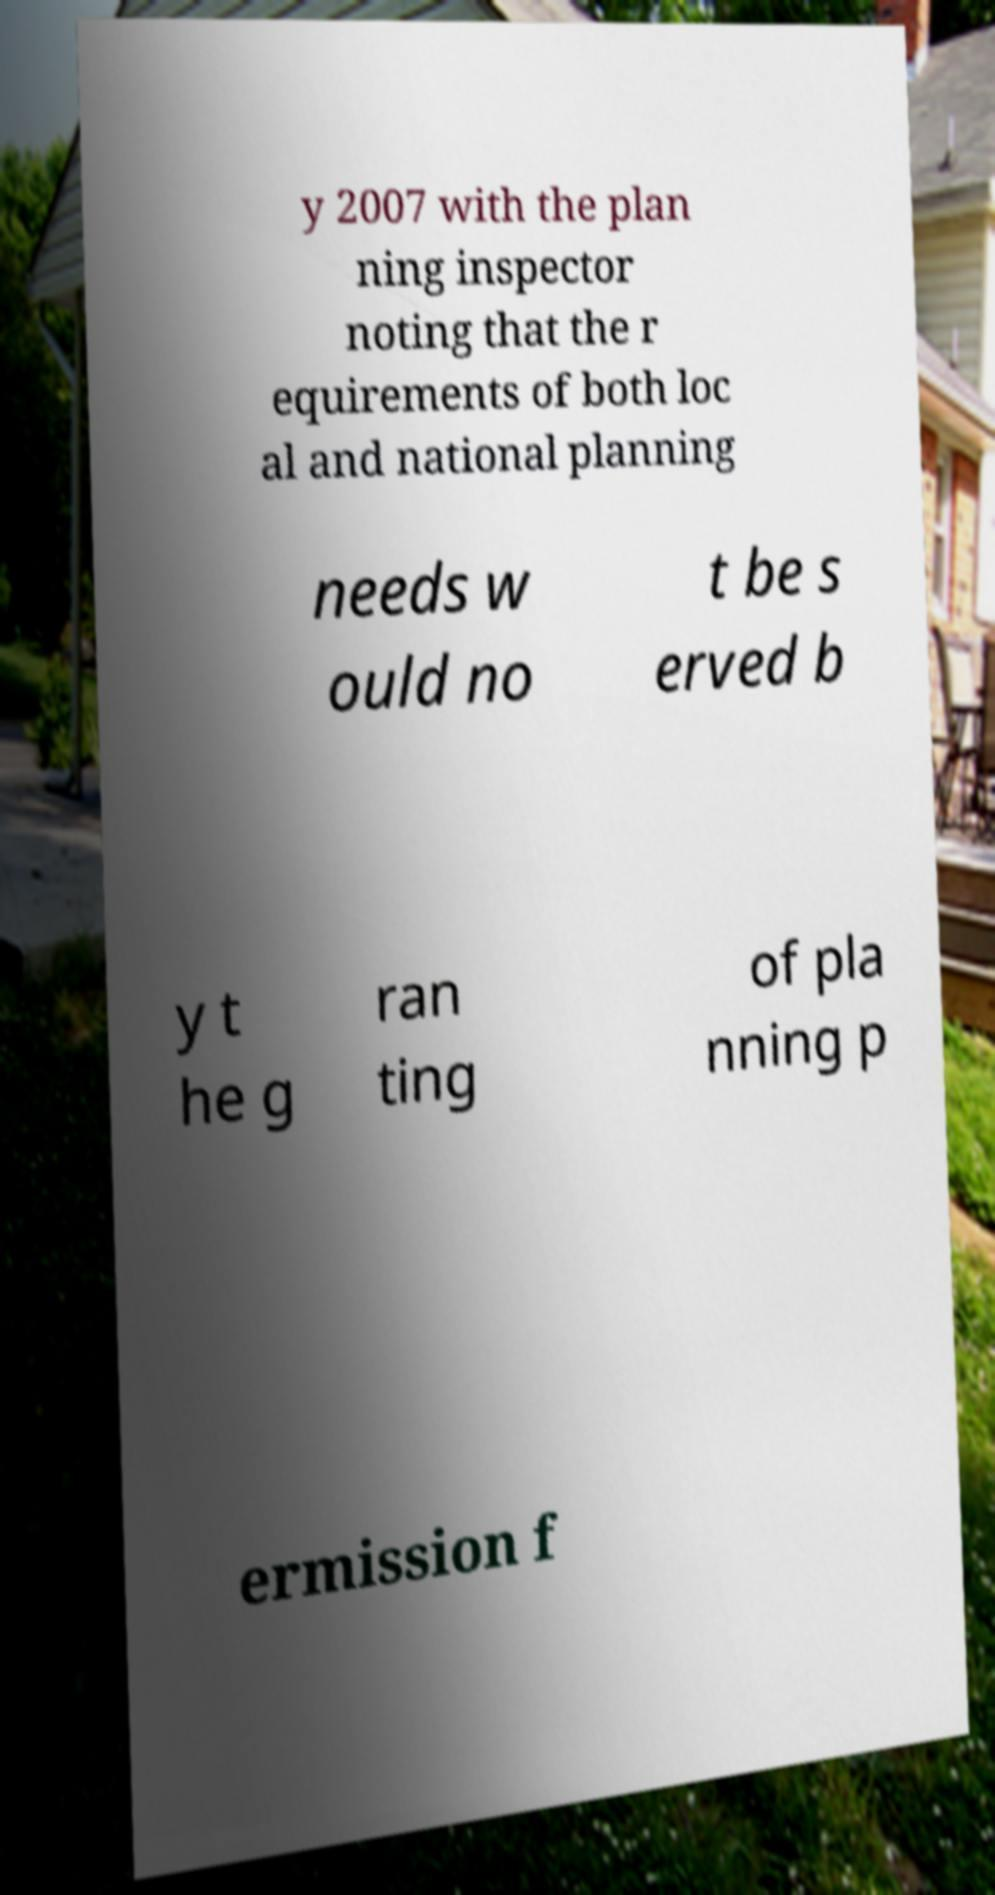Could you assist in decoding the text presented in this image and type it out clearly? y 2007 with the plan ning inspector noting that the r equirements of both loc al and national planning needs w ould no t be s erved b y t he g ran ting of pla nning p ermission f 